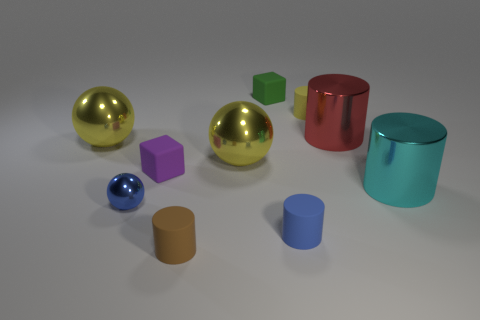What number of objects are either rubber cylinders that are to the right of the small blue cylinder or cubes?
Make the answer very short. 3. Are there any other things that are the same material as the large red thing?
Your answer should be compact. Yes. How many big objects are both to the left of the small green thing and on the right side of the large red object?
Provide a succinct answer. 0. How many things are large spheres on the left side of the small blue ball or yellow metal objects that are left of the small brown object?
Give a very brief answer. 1. How many other things are the same shape as the small purple matte thing?
Keep it short and to the point. 1. Is the color of the ball that is right of the brown cylinder the same as the small shiny sphere?
Your answer should be compact. No. How many other objects are there of the same size as the blue ball?
Provide a short and direct response. 5. Do the blue ball and the purple thing have the same material?
Provide a short and direct response. No. The large metal thing that is in front of the rubber cube that is in front of the green thing is what color?
Provide a succinct answer. Cyan. The brown matte object that is the same shape as the big red object is what size?
Offer a very short reply. Small. 